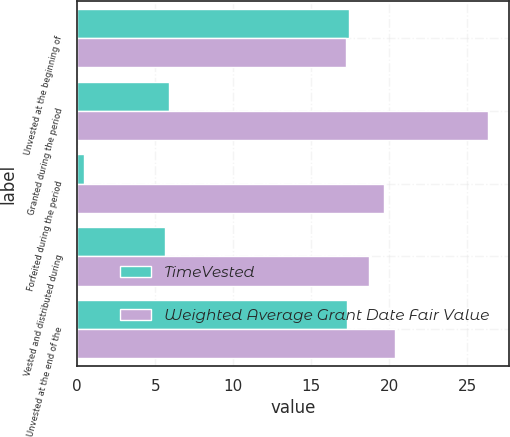<chart> <loc_0><loc_0><loc_500><loc_500><stacked_bar_chart><ecel><fcel>Unvested at the beginning of<fcel>Granted during the period<fcel>Forfeited during the period<fcel>Vested and distributed during<fcel>Unvested at the end of the<nl><fcel>TimeVested<fcel>17.4<fcel>5.9<fcel>0.4<fcel>5.6<fcel>17.3<nl><fcel>Weighted Average Grant Date Fair Value<fcel>17.25<fcel>26.34<fcel>19.65<fcel>18.68<fcel>20.34<nl></chart> 